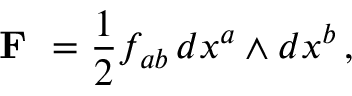Convert formula to latex. <formula><loc_0><loc_0><loc_500><loc_500>{ F } = { \frac { 1 } { 2 } } f _ { a b } \, d x ^ { a } \wedge d x ^ { b } \, ,</formula> 